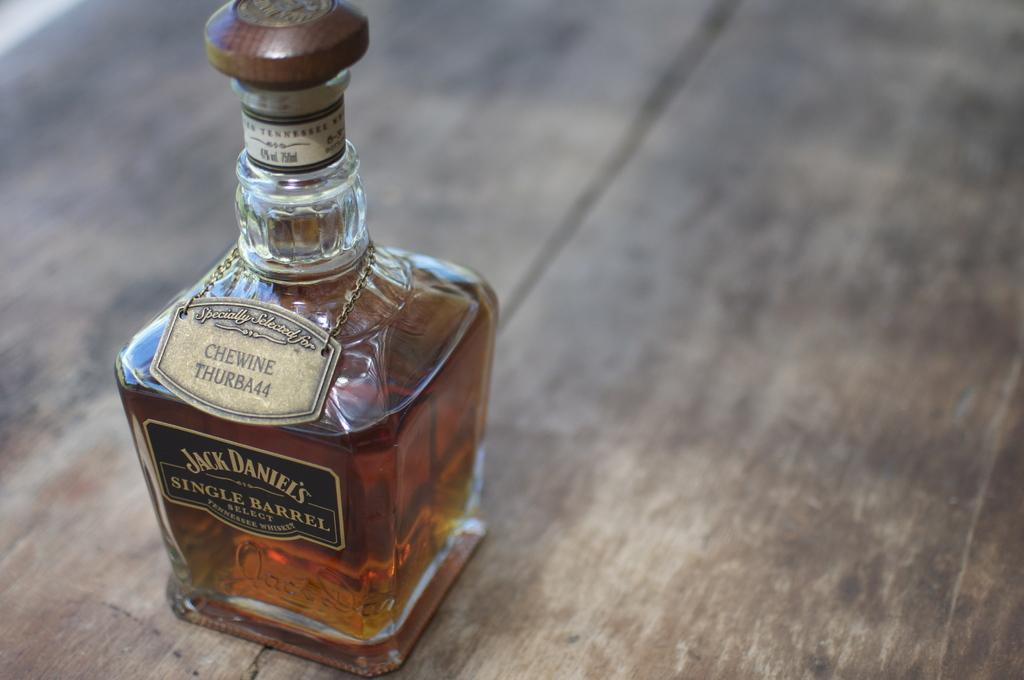What object can be seen in the image? There is a bottle in the image. What type of sign can be seen on the farm in the image? There is no sign or farm present in the image; it only features a bottle. How does the society depicted in the image interact with the bottle? There is no society depicted in the image, as it only features a bottle. 